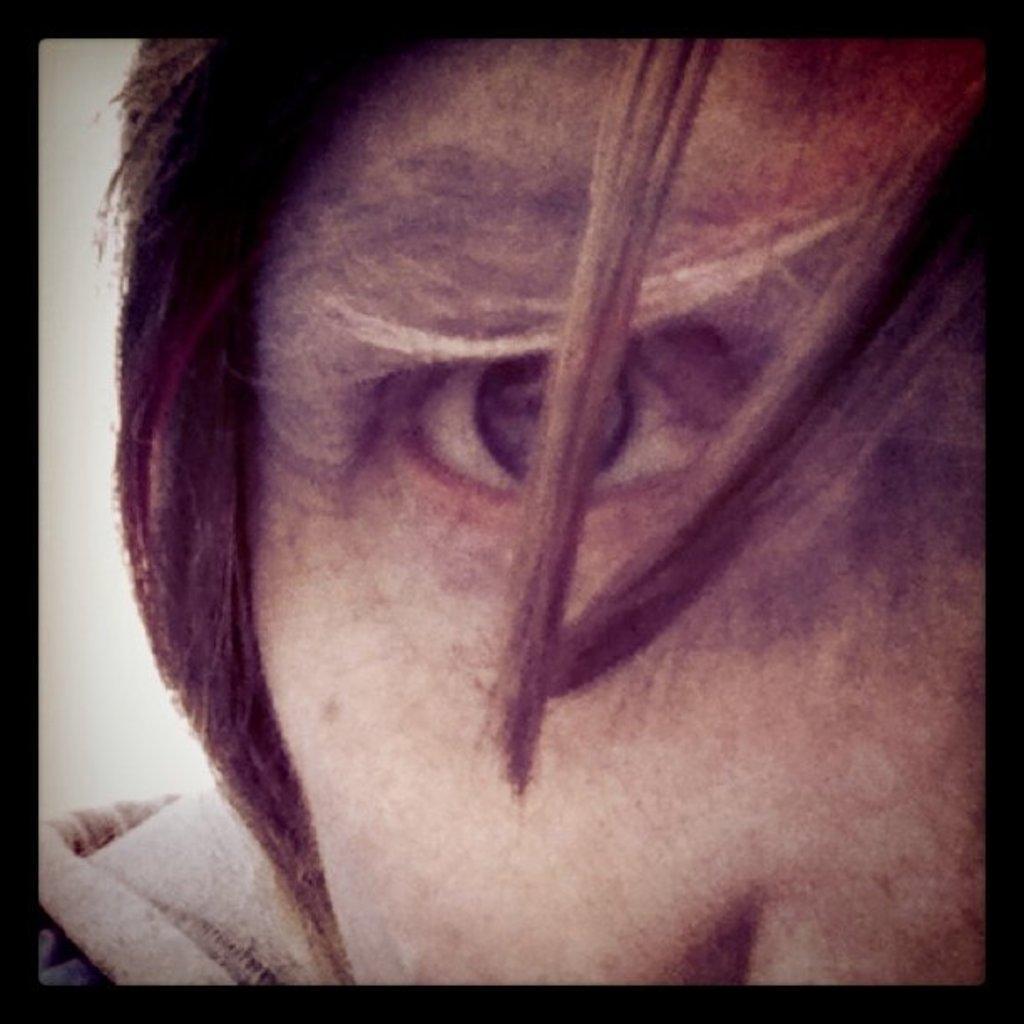Could you give a brief overview of what you see in this image? In this image I can see the person's face and the black color boundaries. 